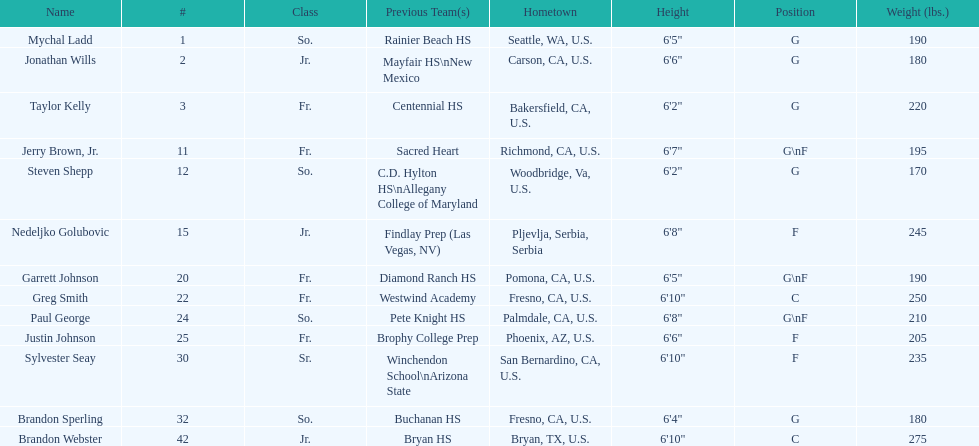Could you help me parse every detail presented in this table? {'header': ['Name', '#', 'Class', 'Previous Team(s)', 'Hometown', 'Height', 'Position', 'Weight (lbs.)'], 'rows': [['Mychal Ladd', '1', 'So.', 'Rainier Beach HS', 'Seattle, WA, U.S.', '6\'5"', 'G', '190'], ['Jonathan Wills', '2', 'Jr.', 'Mayfair HS\\nNew Mexico', 'Carson, CA, U.S.', '6\'6"', 'G', '180'], ['Taylor Kelly', '3', 'Fr.', 'Centennial HS', 'Bakersfield, CA, U.S.', '6\'2"', 'G', '220'], ['Jerry Brown, Jr.', '11', 'Fr.', 'Sacred Heart', 'Richmond, CA, U.S.', '6\'7"', 'G\\nF', '195'], ['Steven Shepp', '12', 'So.', 'C.D. Hylton HS\\nAllegany College of Maryland', 'Woodbridge, Va, U.S.', '6\'2"', 'G', '170'], ['Nedeljko Golubovic', '15', 'Jr.', 'Findlay Prep (Las Vegas, NV)', 'Pljevlja, Serbia, Serbia', '6\'8"', 'F', '245'], ['Garrett Johnson', '20', 'Fr.', 'Diamond Ranch HS', 'Pomona, CA, U.S.', '6\'5"', 'G\\nF', '190'], ['Greg Smith', '22', 'Fr.', 'Westwind Academy', 'Fresno, CA, U.S.', '6\'10"', 'C', '250'], ['Paul George', '24', 'So.', 'Pete Knight HS', 'Palmdale, CA, U.S.', '6\'8"', 'G\\nF', '210'], ['Justin Johnson', '25', 'Fr.', 'Brophy College Prep', 'Phoenix, AZ, U.S.', '6\'6"', 'F', '205'], ['Sylvester Seay', '30', 'Sr.', 'Winchendon School\\nArizona State', 'San Bernardino, CA, U.S.', '6\'10"', 'F', '235'], ['Brandon Sperling', '32', 'So.', 'Buchanan HS', 'Fresno, CA, U.S.', '6\'4"', 'G', '180'], ['Brandon Webster', '42', 'Jr.', 'Bryan HS', 'Bryan, TX, U.S.', '6\'10"', 'C', '275']]} How many players hometowns are outside of california? 5. 